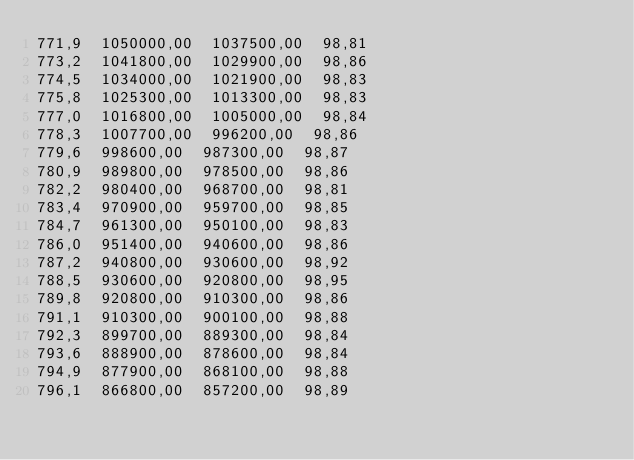Convert code to text. <code><loc_0><loc_0><loc_500><loc_500><_SML_>771,9  1050000,00  1037500,00  98,81
773,2  1041800,00  1029900,00  98,86
774,5  1034000,00  1021900,00  98,83
775,8  1025300,00  1013300,00  98,83
777,0  1016800,00  1005000,00  98,84
778,3  1007700,00  996200,00  98,86
779,6  998600,00  987300,00  98,87
780,9  989800,00  978500,00  98,86
782,2  980400,00  968700,00  98,81
783,4  970900,00  959700,00  98,85
784,7  961300,00  950100,00  98,83
786,0  951400,00  940600,00  98,86
787,2  940800,00  930600,00  98,92
788,5  930600,00  920800,00  98,95
789,8  920800,00  910300,00  98,86
791,1  910300,00  900100,00  98,88
792,3  899700,00  889300,00  98,84
793,6  888900,00  878600,00  98,84
794,9  877900,00  868100,00  98,88
796,1  866800,00  857200,00  98,89</code> 